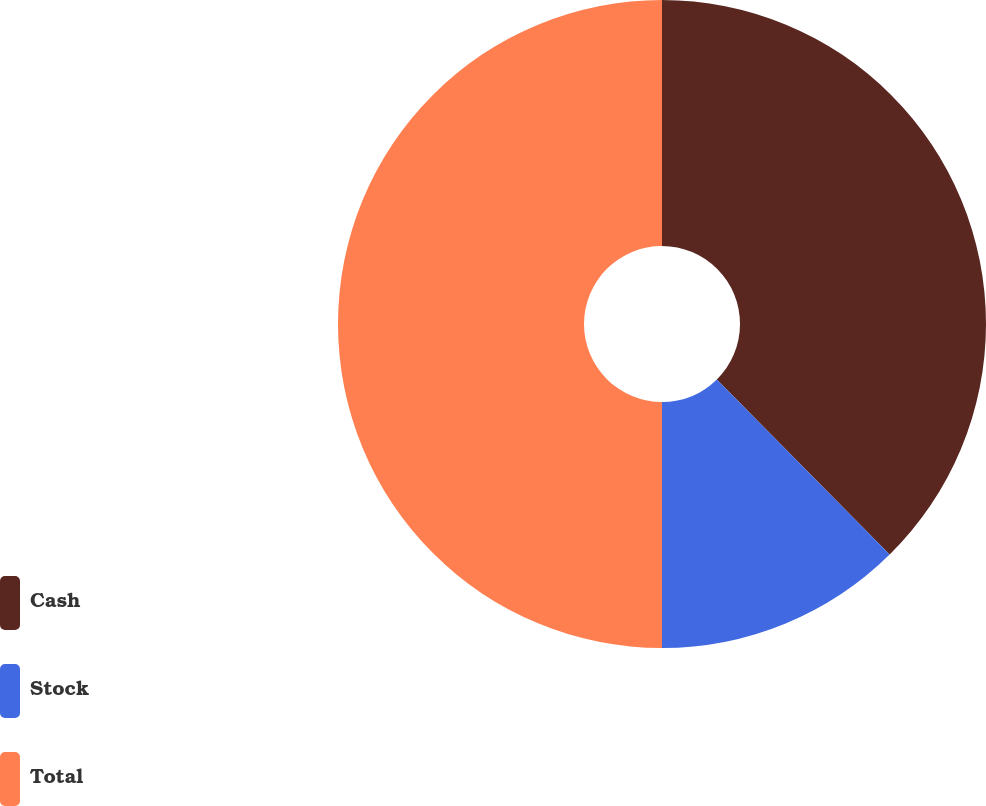Convert chart. <chart><loc_0><loc_0><loc_500><loc_500><pie_chart><fcel>Cash<fcel>Stock<fcel>Total<nl><fcel>37.6%<fcel>12.4%<fcel>50.0%<nl></chart> 